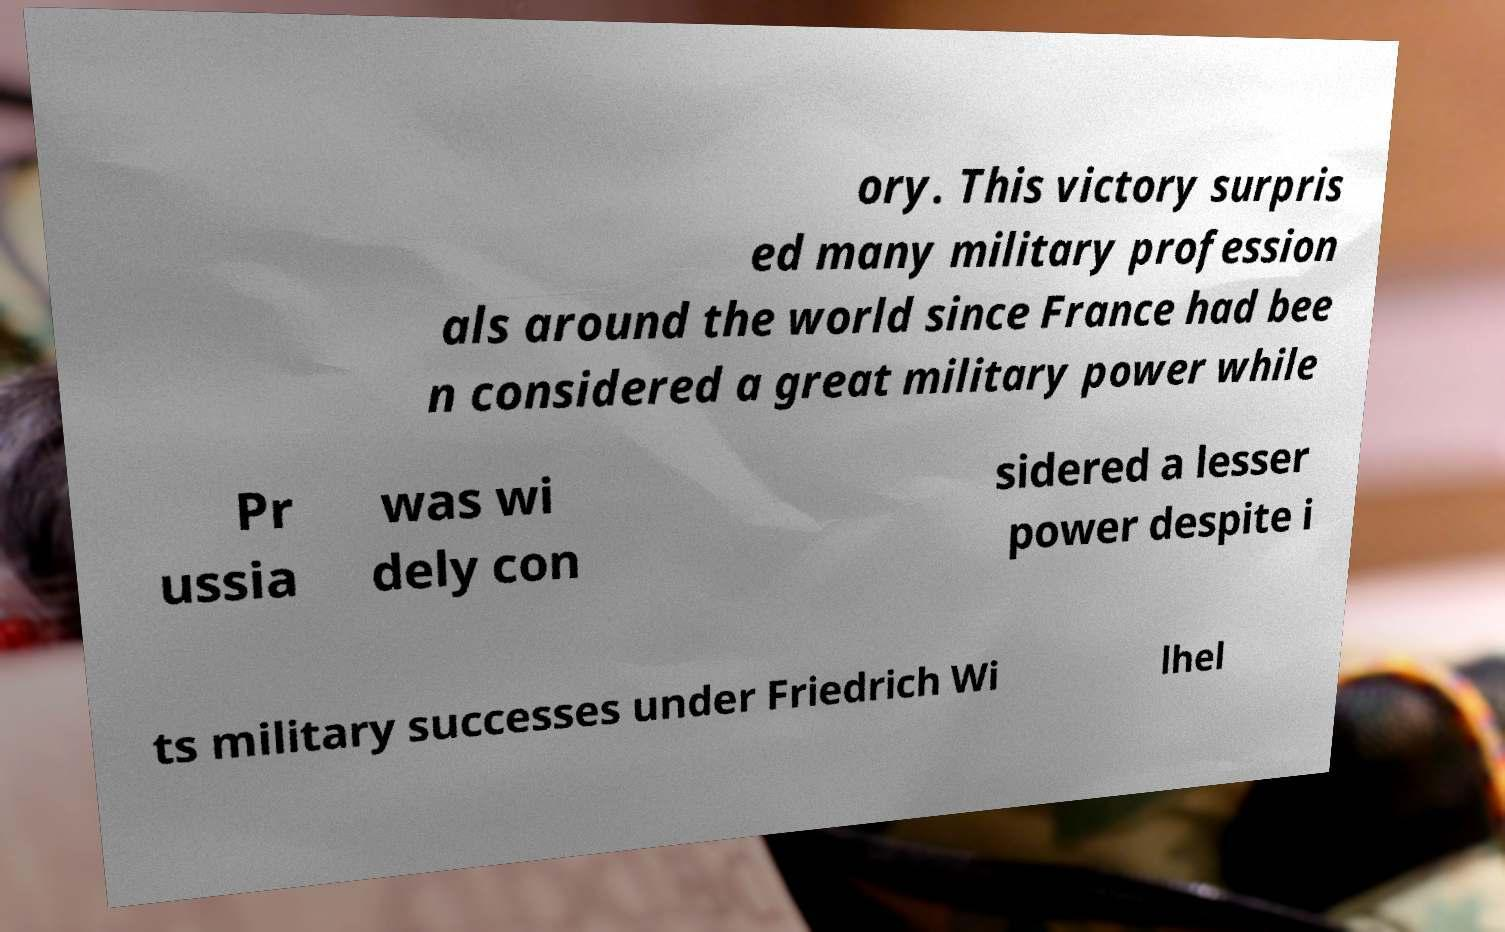Could you extract and type out the text from this image? ory. This victory surpris ed many military profession als around the world since France had bee n considered a great military power while Pr ussia was wi dely con sidered a lesser power despite i ts military successes under Friedrich Wi lhel 